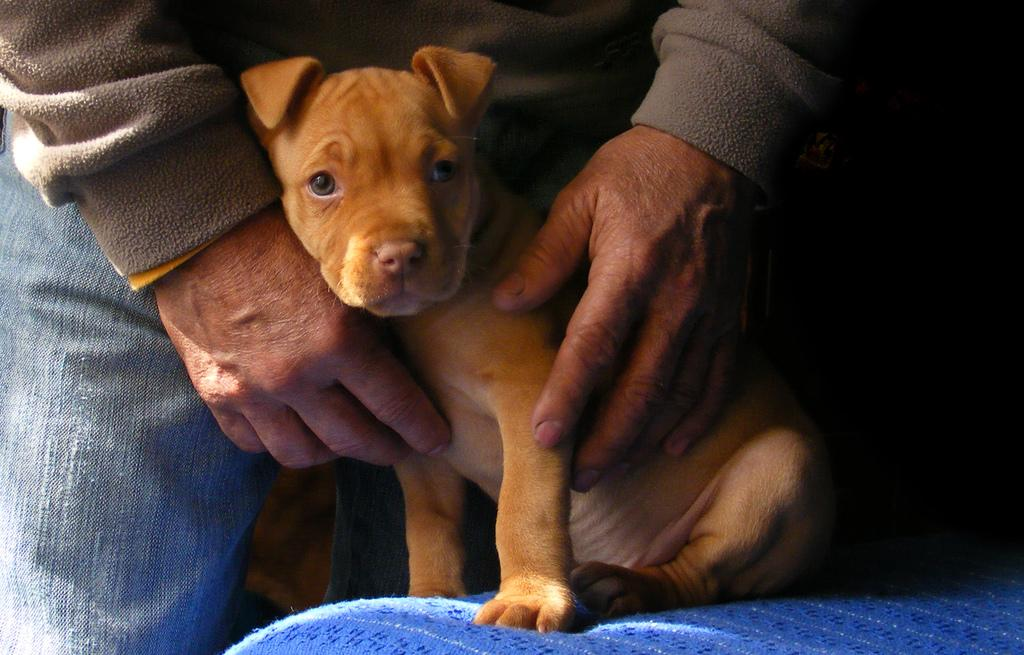What is on the left side of the image? There is a person on the left side of the image. What type of clothing is the person wearing? The person is wearing jeans. What is the person holding in the image? The person is holding a dog. What is the dog sitting on in the image? The dog is on a violet-colored cloth. How would you describe the background of the image? The background of the image is dark in color. What type of toys can be seen in the image? There are no toys visible in the image. How does the horse behave in the image? There is no horse present in the image, so its behavior cannot be determined. 